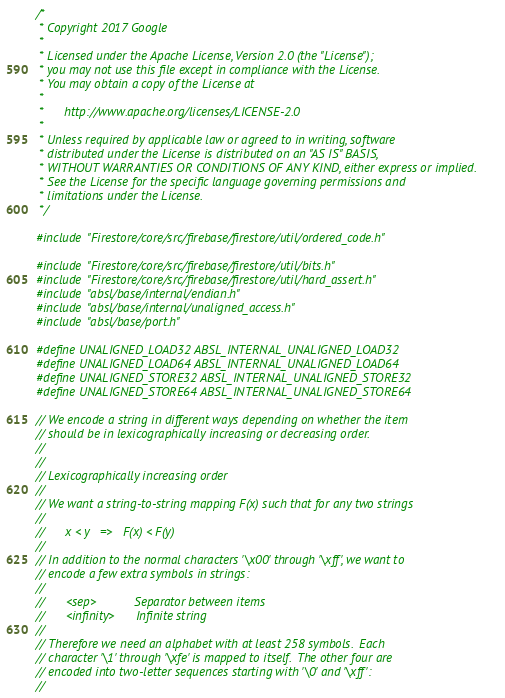Convert code to text. <code><loc_0><loc_0><loc_500><loc_500><_C++_>/*
 * Copyright 2017 Google
 *
 * Licensed under the Apache License, Version 2.0 (the "License");
 * you may not use this file except in compliance with the License.
 * You may obtain a copy of the License at
 *
 *      http://www.apache.org/licenses/LICENSE-2.0
 *
 * Unless required by applicable law or agreed to in writing, software
 * distributed under the License is distributed on an "AS IS" BASIS,
 * WITHOUT WARRANTIES OR CONDITIONS OF ANY KIND, either express or implied.
 * See the License for the specific language governing permissions and
 * limitations under the License.
 */

#include "Firestore/core/src/firebase/firestore/util/ordered_code.h"

#include "Firestore/core/src/firebase/firestore/util/bits.h"
#include "Firestore/core/src/firebase/firestore/util/hard_assert.h"
#include "absl/base/internal/endian.h"
#include "absl/base/internal/unaligned_access.h"
#include "absl/base/port.h"

#define UNALIGNED_LOAD32 ABSL_INTERNAL_UNALIGNED_LOAD32
#define UNALIGNED_LOAD64 ABSL_INTERNAL_UNALIGNED_LOAD64
#define UNALIGNED_STORE32 ABSL_INTERNAL_UNALIGNED_STORE32
#define UNALIGNED_STORE64 ABSL_INTERNAL_UNALIGNED_STORE64

// We encode a string in different ways depending on whether the item
// should be in lexicographically increasing or decreasing order.
//
//
// Lexicographically increasing order
//
// We want a string-to-string mapping F(x) such that for any two strings
//
//      x < y   =>   F(x) < F(y)
//
// In addition to the normal characters '\x00' through '\xff', we want to
// encode a few extra symbols in strings:
//
//      <sep>           Separator between items
//      <infinity>      Infinite string
//
// Therefore we need an alphabet with at least 258 symbols.  Each
// character '\1' through '\xfe' is mapped to itself.  The other four are
// encoded into two-letter sequences starting with '\0' and '\xff':
//</code> 